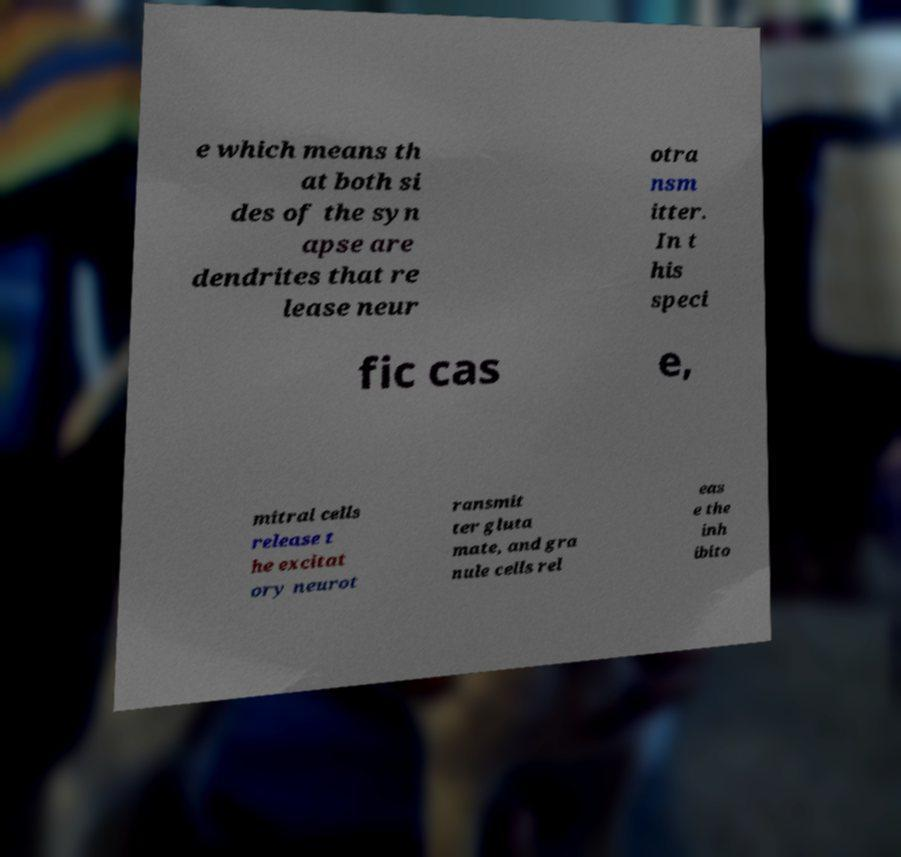For documentation purposes, I need the text within this image transcribed. Could you provide that? e which means th at both si des of the syn apse are dendrites that re lease neur otra nsm itter. In t his speci fic cas e, mitral cells release t he excitat ory neurot ransmit ter gluta mate, and gra nule cells rel eas e the inh ibito 